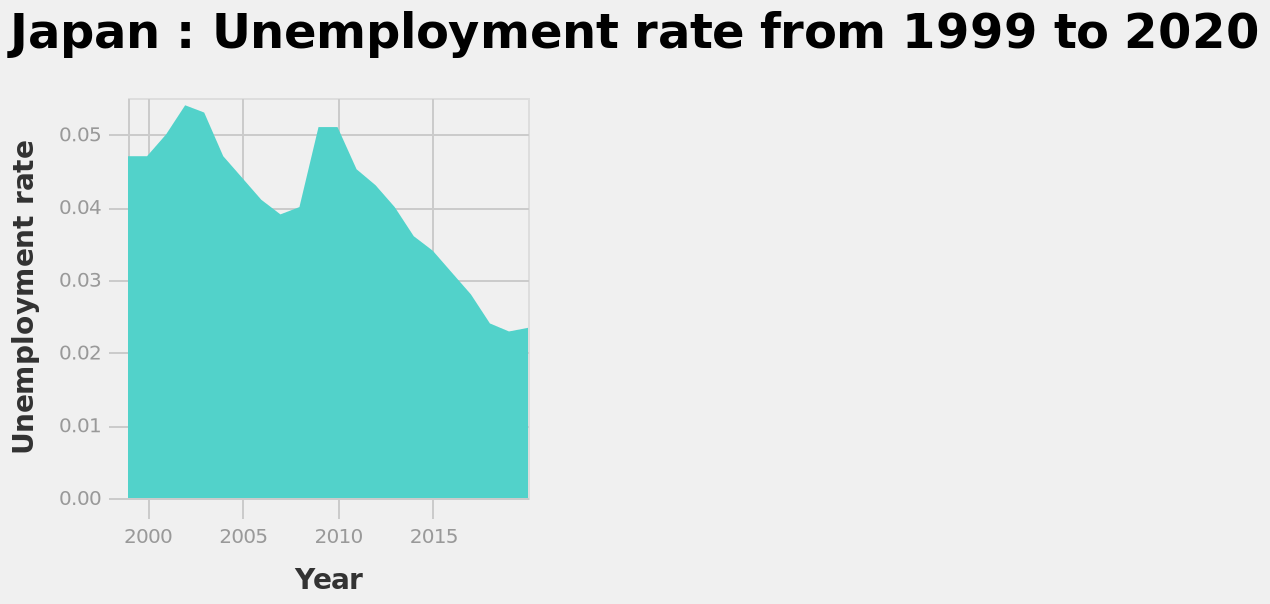<image>
What does the y-axis represent on the area diagram? The y-axis represents the Unemployment rate. In what period does the area plot show the unemployment rate? The area plot shows the unemployment rate from 1999 to 2020. How did the unemployment rate in Japan change between 1999 and 2020?  The unemployment rate in Japan was at its lowest after 2015 but highest between 2000 and 2005. 